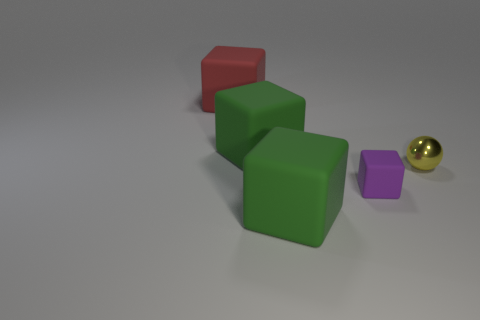What number of other objects are there of the same size as the purple block?
Offer a very short reply. 1. How many small purple things are the same material as the red cube?
Offer a terse response. 1. The shiny sphere is what color?
Your response must be concise. Yellow. There is a big green rubber object that is in front of the small yellow object; is it the same shape as the purple matte object?
Offer a terse response. Yes. What number of objects are either big objects in front of the red matte cube or matte objects?
Offer a very short reply. 4. Are there any large green rubber objects that have the same shape as the yellow shiny thing?
Provide a short and direct response. No. There is a purple thing that is the same size as the yellow sphere; what is its shape?
Offer a very short reply. Cube. There is a green rubber thing that is behind the large green rubber cube in front of the large green rubber cube behind the metal sphere; what shape is it?
Give a very brief answer. Cube. There is a purple thing; is it the same shape as the green rubber thing that is behind the small yellow metal sphere?
Ensure brevity in your answer.  Yes. How many small things are either red objects or green rubber things?
Provide a succinct answer. 0. 